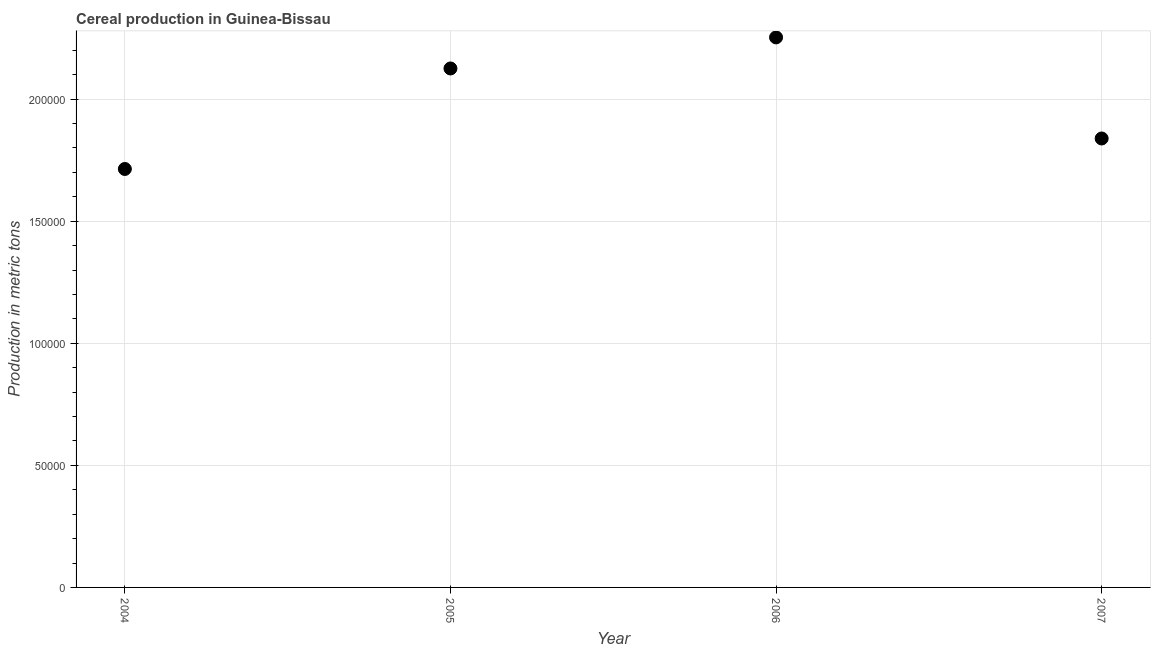What is the cereal production in 2007?
Your answer should be very brief. 1.84e+05. Across all years, what is the maximum cereal production?
Ensure brevity in your answer.  2.25e+05. Across all years, what is the minimum cereal production?
Keep it short and to the point. 1.71e+05. In which year was the cereal production maximum?
Your answer should be compact. 2006. What is the sum of the cereal production?
Provide a short and direct response. 7.93e+05. What is the difference between the cereal production in 2005 and 2006?
Make the answer very short. -1.27e+04. What is the average cereal production per year?
Your response must be concise. 1.98e+05. What is the median cereal production?
Your answer should be compact. 1.98e+05. In how many years, is the cereal production greater than 100000 metric tons?
Offer a terse response. 4. What is the ratio of the cereal production in 2004 to that in 2006?
Provide a short and direct response. 0.76. What is the difference between the highest and the second highest cereal production?
Provide a succinct answer. 1.27e+04. Is the sum of the cereal production in 2004 and 2006 greater than the maximum cereal production across all years?
Your answer should be very brief. Yes. What is the difference between the highest and the lowest cereal production?
Make the answer very short. 5.39e+04. Does the cereal production monotonically increase over the years?
Your answer should be compact. No. How many dotlines are there?
Your response must be concise. 1. How many years are there in the graph?
Offer a terse response. 4. Does the graph contain any zero values?
Your answer should be very brief. No. What is the title of the graph?
Offer a very short reply. Cereal production in Guinea-Bissau. What is the label or title of the X-axis?
Provide a short and direct response. Year. What is the label or title of the Y-axis?
Your response must be concise. Production in metric tons. What is the Production in metric tons in 2004?
Your answer should be very brief. 1.71e+05. What is the Production in metric tons in 2005?
Your answer should be compact. 2.13e+05. What is the Production in metric tons in 2006?
Keep it short and to the point. 2.25e+05. What is the Production in metric tons in 2007?
Your response must be concise. 1.84e+05. What is the difference between the Production in metric tons in 2004 and 2005?
Offer a terse response. -4.12e+04. What is the difference between the Production in metric tons in 2004 and 2006?
Give a very brief answer. -5.39e+04. What is the difference between the Production in metric tons in 2004 and 2007?
Make the answer very short. -1.25e+04. What is the difference between the Production in metric tons in 2005 and 2006?
Keep it short and to the point. -1.27e+04. What is the difference between the Production in metric tons in 2005 and 2007?
Provide a short and direct response. 2.87e+04. What is the difference between the Production in metric tons in 2006 and 2007?
Offer a very short reply. 4.14e+04. What is the ratio of the Production in metric tons in 2004 to that in 2005?
Offer a terse response. 0.81. What is the ratio of the Production in metric tons in 2004 to that in 2006?
Provide a short and direct response. 0.76. What is the ratio of the Production in metric tons in 2004 to that in 2007?
Provide a succinct answer. 0.93. What is the ratio of the Production in metric tons in 2005 to that in 2006?
Keep it short and to the point. 0.94. What is the ratio of the Production in metric tons in 2005 to that in 2007?
Your response must be concise. 1.16. What is the ratio of the Production in metric tons in 2006 to that in 2007?
Ensure brevity in your answer.  1.23. 